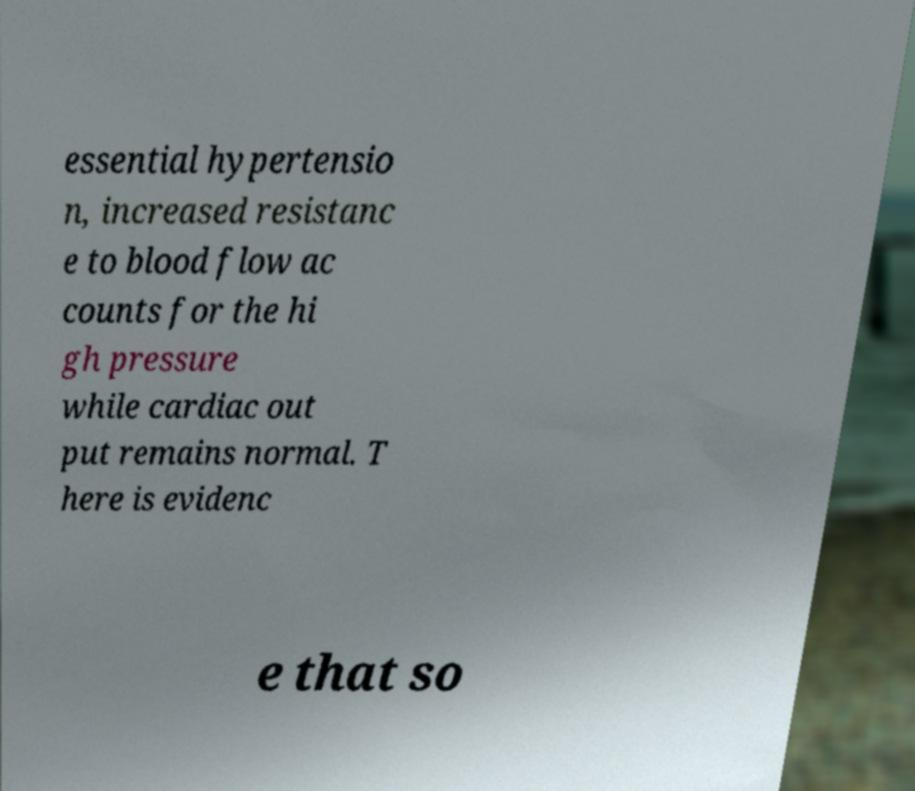What messages or text are displayed in this image? I need them in a readable, typed format. essential hypertensio n, increased resistanc e to blood flow ac counts for the hi gh pressure while cardiac out put remains normal. T here is evidenc e that so 